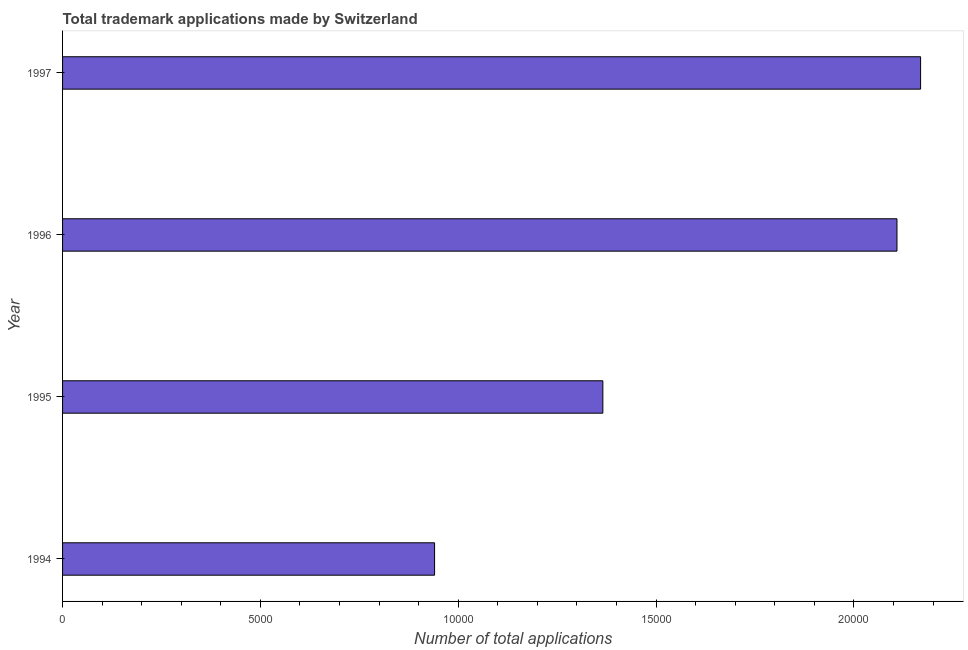Does the graph contain grids?
Give a very brief answer. No. What is the title of the graph?
Offer a terse response. Total trademark applications made by Switzerland. What is the label or title of the X-axis?
Provide a succinct answer. Number of total applications. What is the number of trademark applications in 1996?
Your response must be concise. 2.11e+04. Across all years, what is the maximum number of trademark applications?
Your answer should be compact. 2.17e+04. Across all years, what is the minimum number of trademark applications?
Give a very brief answer. 9402. What is the sum of the number of trademark applications?
Give a very brief answer. 6.58e+04. What is the difference between the number of trademark applications in 1995 and 1997?
Keep it short and to the point. -8030. What is the average number of trademark applications per year?
Your answer should be very brief. 1.65e+04. What is the median number of trademark applications?
Provide a succinct answer. 1.74e+04. In how many years, is the number of trademark applications greater than 18000 ?
Keep it short and to the point. 2. What is the ratio of the number of trademark applications in 1995 to that in 1996?
Offer a very short reply. 0.65. Is the difference between the number of trademark applications in 1994 and 1995 greater than the difference between any two years?
Give a very brief answer. No. What is the difference between the highest and the second highest number of trademark applications?
Give a very brief answer. 597. Is the sum of the number of trademark applications in 1994 and 1995 greater than the maximum number of trademark applications across all years?
Ensure brevity in your answer.  Yes. What is the difference between the highest and the lowest number of trademark applications?
Provide a short and direct response. 1.23e+04. How many bars are there?
Offer a terse response. 4. What is the difference between two consecutive major ticks on the X-axis?
Provide a short and direct response. 5000. What is the Number of total applications in 1994?
Keep it short and to the point. 9402. What is the Number of total applications of 1995?
Your response must be concise. 1.37e+04. What is the Number of total applications of 1996?
Your answer should be very brief. 2.11e+04. What is the Number of total applications of 1997?
Your answer should be compact. 2.17e+04. What is the difference between the Number of total applications in 1994 and 1995?
Keep it short and to the point. -4253. What is the difference between the Number of total applications in 1994 and 1996?
Provide a succinct answer. -1.17e+04. What is the difference between the Number of total applications in 1994 and 1997?
Offer a very short reply. -1.23e+04. What is the difference between the Number of total applications in 1995 and 1996?
Offer a terse response. -7433. What is the difference between the Number of total applications in 1995 and 1997?
Keep it short and to the point. -8030. What is the difference between the Number of total applications in 1996 and 1997?
Ensure brevity in your answer.  -597. What is the ratio of the Number of total applications in 1994 to that in 1995?
Ensure brevity in your answer.  0.69. What is the ratio of the Number of total applications in 1994 to that in 1996?
Offer a very short reply. 0.45. What is the ratio of the Number of total applications in 1994 to that in 1997?
Make the answer very short. 0.43. What is the ratio of the Number of total applications in 1995 to that in 1996?
Ensure brevity in your answer.  0.65. What is the ratio of the Number of total applications in 1995 to that in 1997?
Your answer should be very brief. 0.63. What is the ratio of the Number of total applications in 1996 to that in 1997?
Make the answer very short. 0.97. 